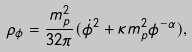<formula> <loc_0><loc_0><loc_500><loc_500>\rho _ { \phi } = \frac { m _ { p } ^ { 2 } } { 3 2 \pi } ( \dot { \phi } ^ { 2 } + \kappa m _ { p } ^ { 2 } \phi ^ { - \alpha } ) ,</formula> 